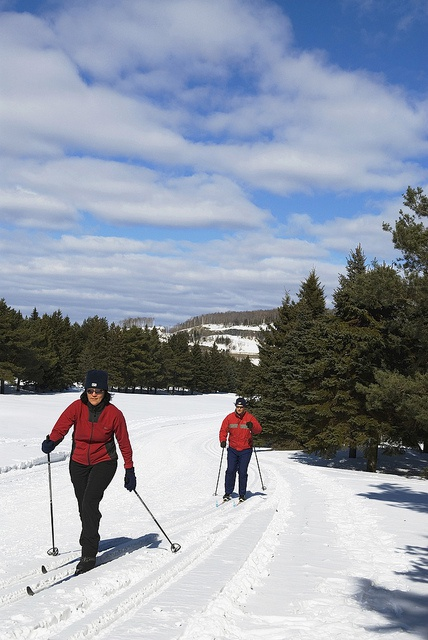Describe the objects in this image and their specific colors. I can see people in gray, black, brown, white, and maroon tones, people in gray, black, brown, navy, and white tones, skis in gray, lightgray, darkgray, and black tones, and skis in gray, lightgray, darkgray, and lightblue tones in this image. 